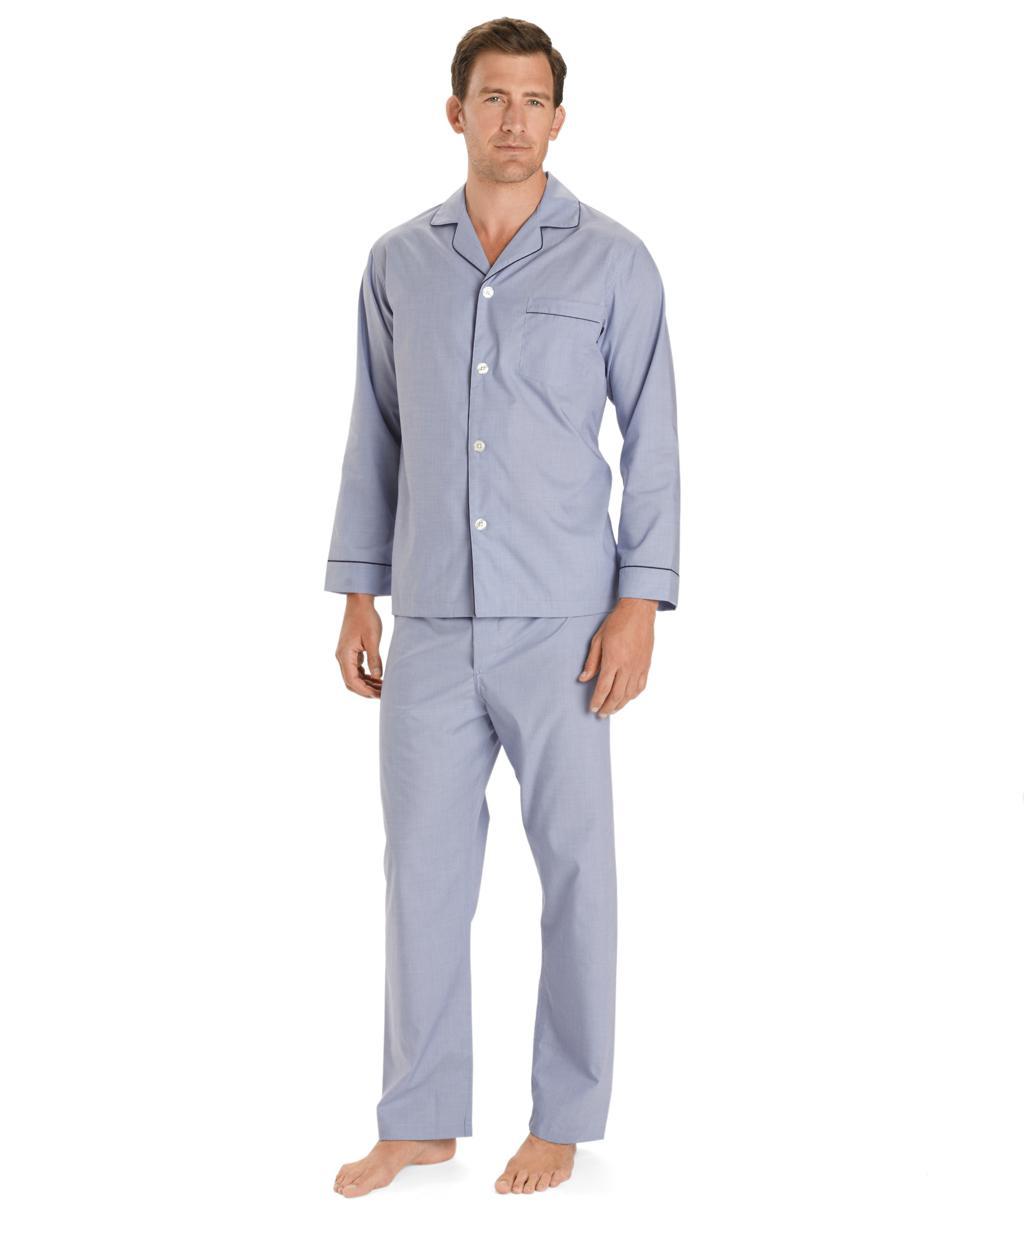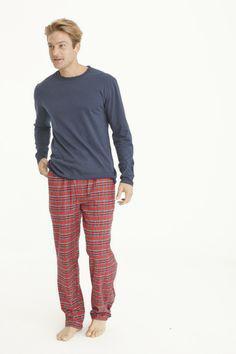The first image is the image on the left, the second image is the image on the right. Assess this claim about the two images: "A model is wearing a one-piece pajama with an all-over print.". Correct or not? Answer yes or no. No. The first image is the image on the left, the second image is the image on the right. For the images shown, is this caption "The image on the left does not have a white background" true? Answer yes or no. No. 